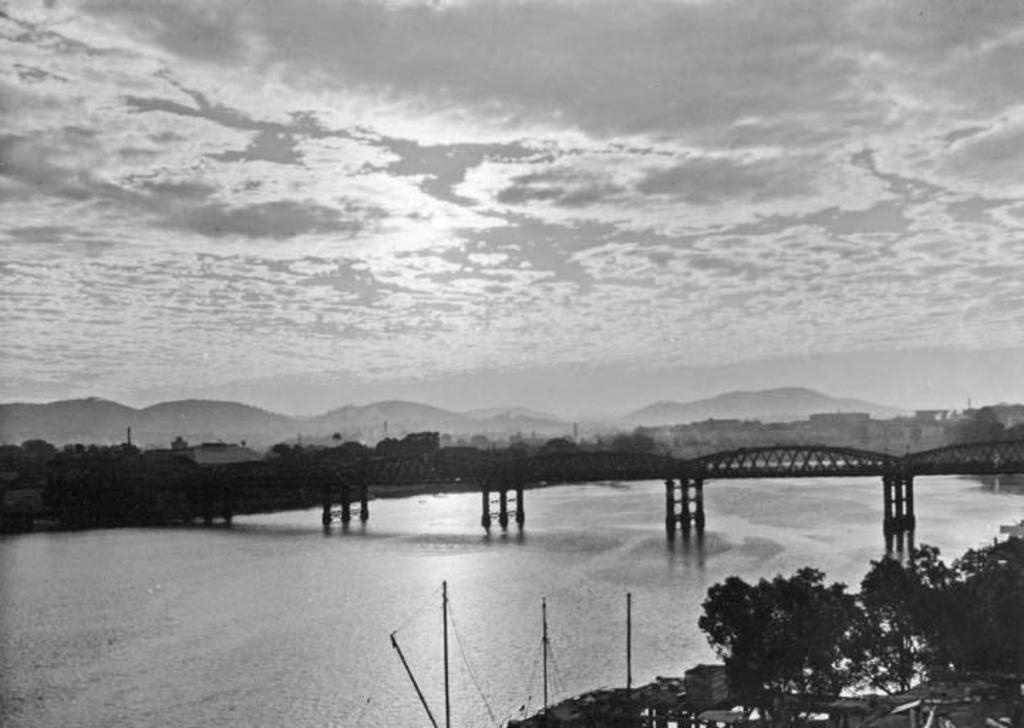What type of structure can be seen in the image? There is a bridge in the image. What is located beneath the bridge? Water is visible under the bridge. What else can be seen in the image besides the bridge and water? There are buildings, trees, and various objects in the image. What can be seen in the distance in the background of the image? Mountains and the sky are visible in the background of the image. What type of authority is depicted in the image? There is no authority figure present in the image; it primarily features a bridge, water, buildings, trees, and objects. What route can be taken to cross the bridge in the image? The image does not provide information about a specific route to cross the bridge. 